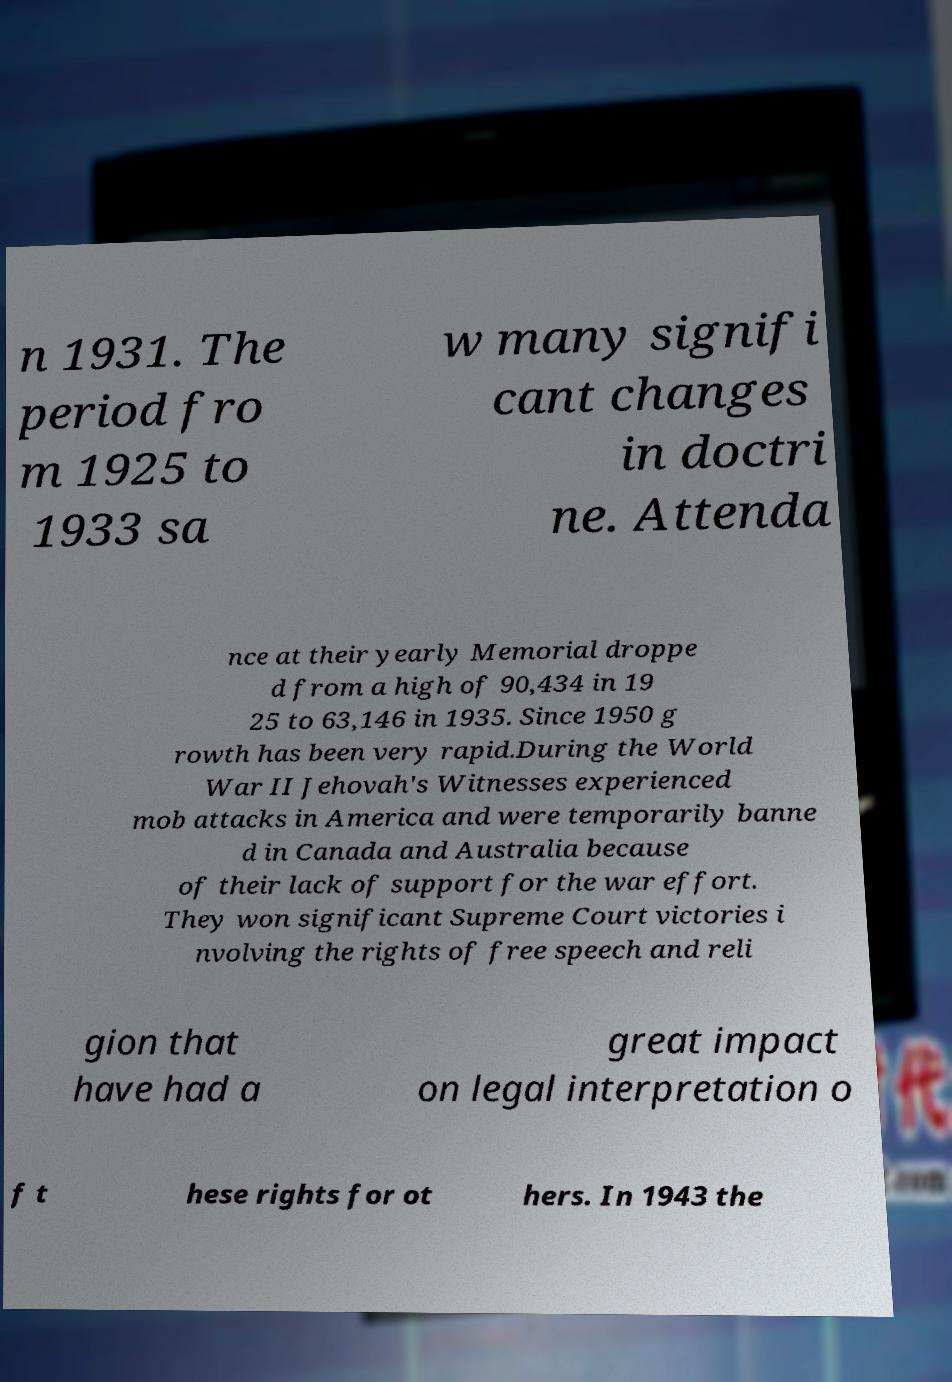I need the written content from this picture converted into text. Can you do that? n 1931. The period fro m 1925 to 1933 sa w many signifi cant changes in doctri ne. Attenda nce at their yearly Memorial droppe d from a high of 90,434 in 19 25 to 63,146 in 1935. Since 1950 g rowth has been very rapid.During the World War II Jehovah's Witnesses experienced mob attacks in America and were temporarily banne d in Canada and Australia because of their lack of support for the war effort. They won significant Supreme Court victories i nvolving the rights of free speech and reli gion that have had a great impact on legal interpretation o f t hese rights for ot hers. In 1943 the 